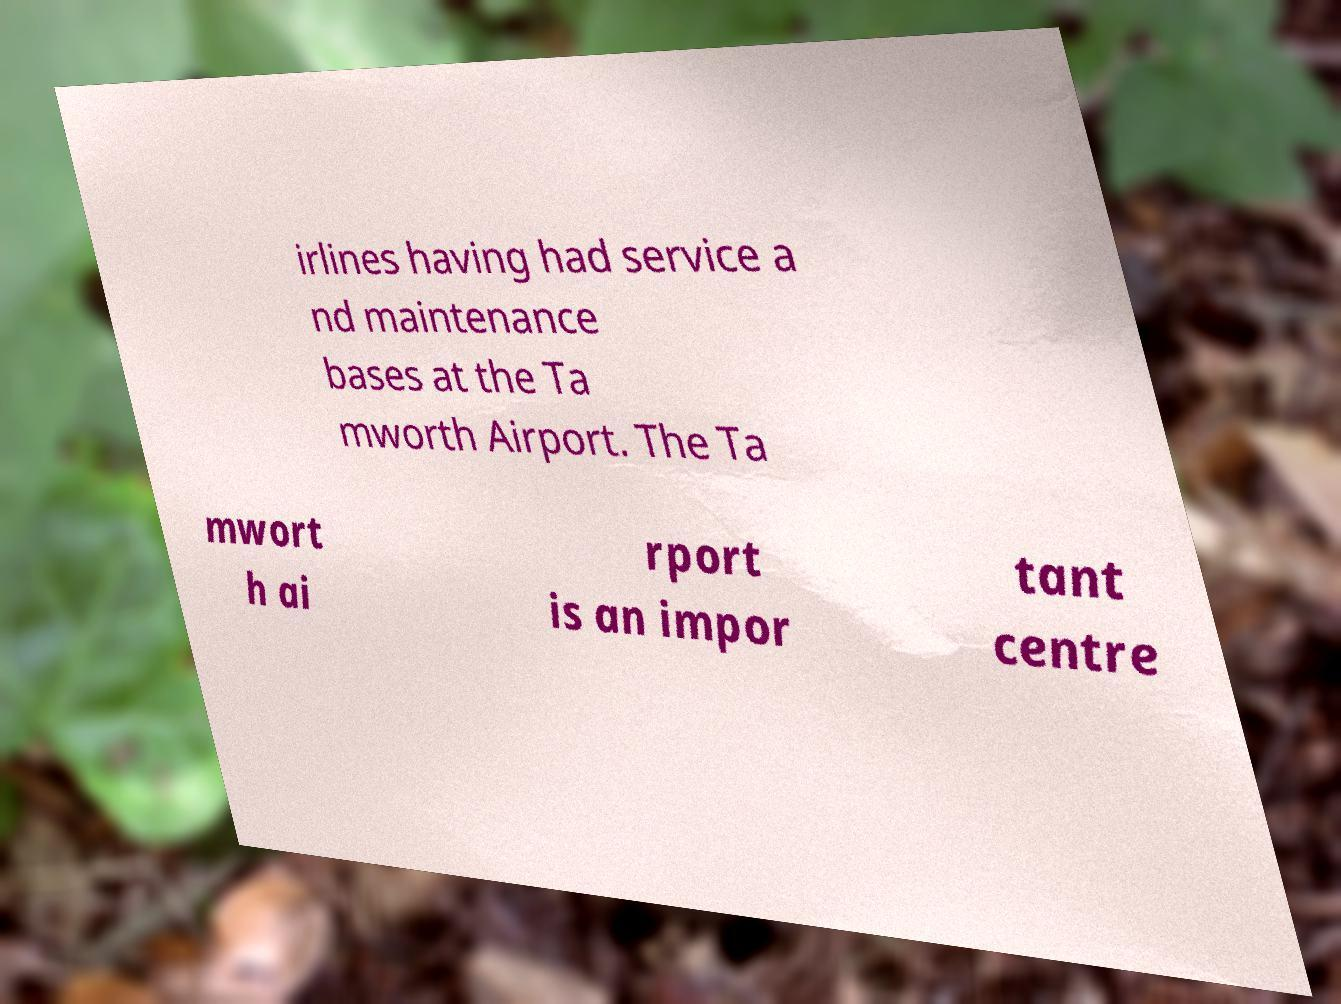For documentation purposes, I need the text within this image transcribed. Could you provide that? irlines having had service a nd maintenance bases at the Ta mworth Airport. The Ta mwort h ai rport is an impor tant centre 